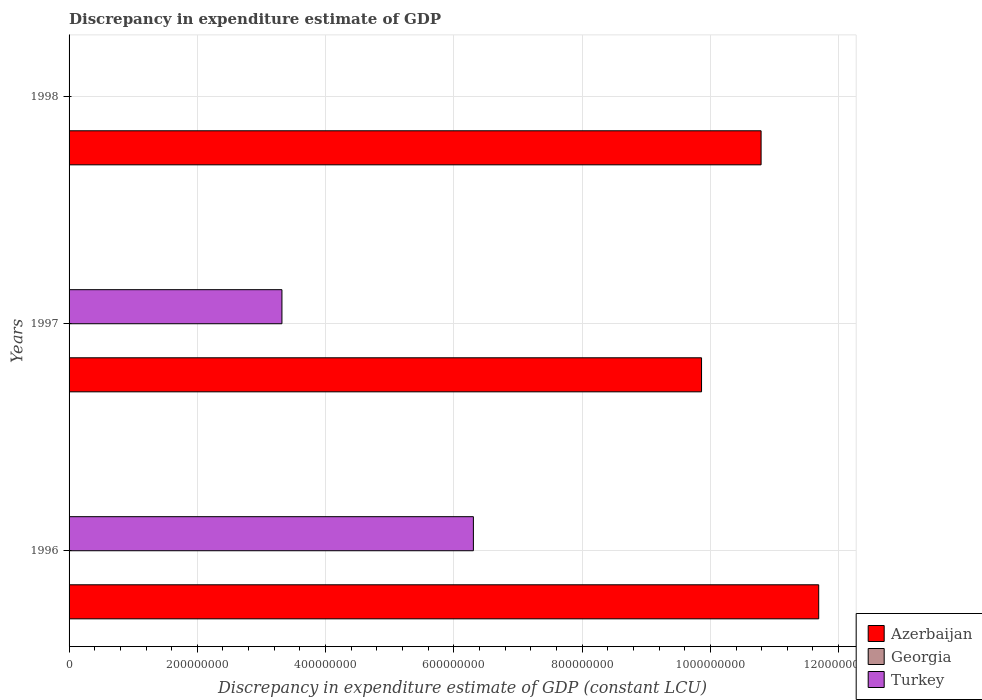How many different coloured bars are there?
Your answer should be very brief. 2. Are the number of bars per tick equal to the number of legend labels?
Your answer should be compact. No. In how many cases, is the number of bars for a given year not equal to the number of legend labels?
Ensure brevity in your answer.  3. What is the discrepancy in expenditure estimate of GDP in Turkey in 1998?
Provide a succinct answer. 200. Across all years, what is the maximum discrepancy in expenditure estimate of GDP in Azerbaijan?
Provide a short and direct response. 1.17e+09. Across all years, what is the minimum discrepancy in expenditure estimate of GDP in Azerbaijan?
Ensure brevity in your answer.  9.86e+08. What is the total discrepancy in expenditure estimate of GDP in Azerbaijan in the graph?
Ensure brevity in your answer.  3.23e+09. What is the difference between the discrepancy in expenditure estimate of GDP in Azerbaijan in 1996 and that in 1997?
Ensure brevity in your answer.  1.83e+08. What is the difference between the discrepancy in expenditure estimate of GDP in Azerbaijan in 1996 and the discrepancy in expenditure estimate of GDP in Georgia in 1997?
Keep it short and to the point. 1.17e+09. What is the average discrepancy in expenditure estimate of GDP in Azerbaijan per year?
Your response must be concise. 1.08e+09. In the year 1996, what is the difference between the discrepancy in expenditure estimate of GDP in Turkey and discrepancy in expenditure estimate of GDP in Azerbaijan?
Your response must be concise. -5.38e+08. What is the ratio of the discrepancy in expenditure estimate of GDP in Turkey in 1996 to that in 1997?
Provide a succinct answer. 1.9. Is the discrepancy in expenditure estimate of GDP in Turkey in 1996 less than that in 1997?
Provide a succinct answer. No. Is the difference between the discrepancy in expenditure estimate of GDP in Turkey in 1996 and 1998 greater than the difference between the discrepancy in expenditure estimate of GDP in Azerbaijan in 1996 and 1998?
Provide a short and direct response. Yes. What is the difference between the highest and the second highest discrepancy in expenditure estimate of GDP in Turkey?
Offer a terse response. 2.99e+08. What is the difference between the highest and the lowest discrepancy in expenditure estimate of GDP in Azerbaijan?
Offer a very short reply. 1.83e+08. Is the sum of the discrepancy in expenditure estimate of GDP in Turkey in 1996 and 1998 greater than the maximum discrepancy in expenditure estimate of GDP in Azerbaijan across all years?
Offer a very short reply. No. Is it the case that in every year, the sum of the discrepancy in expenditure estimate of GDP in Turkey and discrepancy in expenditure estimate of GDP in Georgia is greater than the discrepancy in expenditure estimate of GDP in Azerbaijan?
Provide a succinct answer. No. Are all the bars in the graph horizontal?
Give a very brief answer. Yes. What is the difference between two consecutive major ticks on the X-axis?
Provide a succinct answer. 2.00e+08. Does the graph contain any zero values?
Your answer should be compact. Yes. Where does the legend appear in the graph?
Your answer should be compact. Bottom right. What is the title of the graph?
Give a very brief answer. Discrepancy in expenditure estimate of GDP. Does "Andorra" appear as one of the legend labels in the graph?
Your answer should be compact. No. What is the label or title of the X-axis?
Your answer should be very brief. Discrepancy in expenditure estimate of GDP (constant LCU). What is the label or title of the Y-axis?
Your response must be concise. Years. What is the Discrepancy in expenditure estimate of GDP (constant LCU) in Azerbaijan in 1996?
Your response must be concise. 1.17e+09. What is the Discrepancy in expenditure estimate of GDP (constant LCU) in Georgia in 1996?
Provide a succinct answer. 0. What is the Discrepancy in expenditure estimate of GDP (constant LCU) of Turkey in 1996?
Offer a terse response. 6.30e+08. What is the Discrepancy in expenditure estimate of GDP (constant LCU) of Azerbaijan in 1997?
Provide a short and direct response. 9.86e+08. What is the Discrepancy in expenditure estimate of GDP (constant LCU) of Georgia in 1997?
Make the answer very short. 0. What is the Discrepancy in expenditure estimate of GDP (constant LCU) in Turkey in 1997?
Your answer should be compact. 3.32e+08. What is the Discrepancy in expenditure estimate of GDP (constant LCU) in Azerbaijan in 1998?
Ensure brevity in your answer.  1.08e+09. What is the Discrepancy in expenditure estimate of GDP (constant LCU) of Georgia in 1998?
Ensure brevity in your answer.  0. What is the Discrepancy in expenditure estimate of GDP (constant LCU) in Turkey in 1998?
Provide a short and direct response. 200. Across all years, what is the maximum Discrepancy in expenditure estimate of GDP (constant LCU) in Azerbaijan?
Your response must be concise. 1.17e+09. Across all years, what is the maximum Discrepancy in expenditure estimate of GDP (constant LCU) of Turkey?
Provide a succinct answer. 6.30e+08. Across all years, what is the minimum Discrepancy in expenditure estimate of GDP (constant LCU) of Azerbaijan?
Provide a succinct answer. 9.86e+08. What is the total Discrepancy in expenditure estimate of GDP (constant LCU) in Azerbaijan in the graph?
Give a very brief answer. 3.23e+09. What is the total Discrepancy in expenditure estimate of GDP (constant LCU) of Georgia in the graph?
Make the answer very short. 0. What is the total Discrepancy in expenditure estimate of GDP (constant LCU) of Turkey in the graph?
Ensure brevity in your answer.  9.62e+08. What is the difference between the Discrepancy in expenditure estimate of GDP (constant LCU) of Azerbaijan in 1996 and that in 1997?
Your answer should be compact. 1.83e+08. What is the difference between the Discrepancy in expenditure estimate of GDP (constant LCU) in Turkey in 1996 and that in 1997?
Ensure brevity in your answer.  2.99e+08. What is the difference between the Discrepancy in expenditure estimate of GDP (constant LCU) in Azerbaijan in 1996 and that in 1998?
Provide a short and direct response. 8.98e+07. What is the difference between the Discrepancy in expenditure estimate of GDP (constant LCU) in Turkey in 1996 and that in 1998?
Offer a terse response. 6.30e+08. What is the difference between the Discrepancy in expenditure estimate of GDP (constant LCU) of Azerbaijan in 1997 and that in 1998?
Your answer should be compact. -9.29e+07. What is the difference between the Discrepancy in expenditure estimate of GDP (constant LCU) of Turkey in 1997 and that in 1998?
Provide a short and direct response. 3.32e+08. What is the difference between the Discrepancy in expenditure estimate of GDP (constant LCU) in Azerbaijan in 1996 and the Discrepancy in expenditure estimate of GDP (constant LCU) in Turkey in 1997?
Make the answer very short. 8.37e+08. What is the difference between the Discrepancy in expenditure estimate of GDP (constant LCU) in Azerbaijan in 1996 and the Discrepancy in expenditure estimate of GDP (constant LCU) in Turkey in 1998?
Ensure brevity in your answer.  1.17e+09. What is the difference between the Discrepancy in expenditure estimate of GDP (constant LCU) of Azerbaijan in 1997 and the Discrepancy in expenditure estimate of GDP (constant LCU) of Turkey in 1998?
Offer a very short reply. 9.86e+08. What is the average Discrepancy in expenditure estimate of GDP (constant LCU) in Azerbaijan per year?
Ensure brevity in your answer.  1.08e+09. What is the average Discrepancy in expenditure estimate of GDP (constant LCU) of Turkey per year?
Keep it short and to the point. 3.21e+08. In the year 1996, what is the difference between the Discrepancy in expenditure estimate of GDP (constant LCU) in Azerbaijan and Discrepancy in expenditure estimate of GDP (constant LCU) in Turkey?
Offer a very short reply. 5.38e+08. In the year 1997, what is the difference between the Discrepancy in expenditure estimate of GDP (constant LCU) of Azerbaijan and Discrepancy in expenditure estimate of GDP (constant LCU) of Turkey?
Ensure brevity in your answer.  6.54e+08. In the year 1998, what is the difference between the Discrepancy in expenditure estimate of GDP (constant LCU) in Azerbaijan and Discrepancy in expenditure estimate of GDP (constant LCU) in Turkey?
Make the answer very short. 1.08e+09. What is the ratio of the Discrepancy in expenditure estimate of GDP (constant LCU) in Azerbaijan in 1996 to that in 1997?
Provide a short and direct response. 1.19. What is the ratio of the Discrepancy in expenditure estimate of GDP (constant LCU) of Turkey in 1996 to that in 1997?
Provide a short and direct response. 1.9. What is the ratio of the Discrepancy in expenditure estimate of GDP (constant LCU) in Azerbaijan in 1996 to that in 1998?
Your answer should be compact. 1.08. What is the ratio of the Discrepancy in expenditure estimate of GDP (constant LCU) in Turkey in 1996 to that in 1998?
Provide a short and direct response. 3.15e+06. What is the ratio of the Discrepancy in expenditure estimate of GDP (constant LCU) of Azerbaijan in 1997 to that in 1998?
Your answer should be very brief. 0.91. What is the ratio of the Discrepancy in expenditure estimate of GDP (constant LCU) of Turkey in 1997 to that in 1998?
Ensure brevity in your answer.  1.66e+06. What is the difference between the highest and the second highest Discrepancy in expenditure estimate of GDP (constant LCU) of Azerbaijan?
Provide a short and direct response. 8.98e+07. What is the difference between the highest and the second highest Discrepancy in expenditure estimate of GDP (constant LCU) in Turkey?
Offer a terse response. 2.99e+08. What is the difference between the highest and the lowest Discrepancy in expenditure estimate of GDP (constant LCU) in Azerbaijan?
Give a very brief answer. 1.83e+08. What is the difference between the highest and the lowest Discrepancy in expenditure estimate of GDP (constant LCU) of Turkey?
Give a very brief answer. 6.30e+08. 